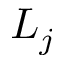<formula> <loc_0><loc_0><loc_500><loc_500>L _ { j }</formula> 